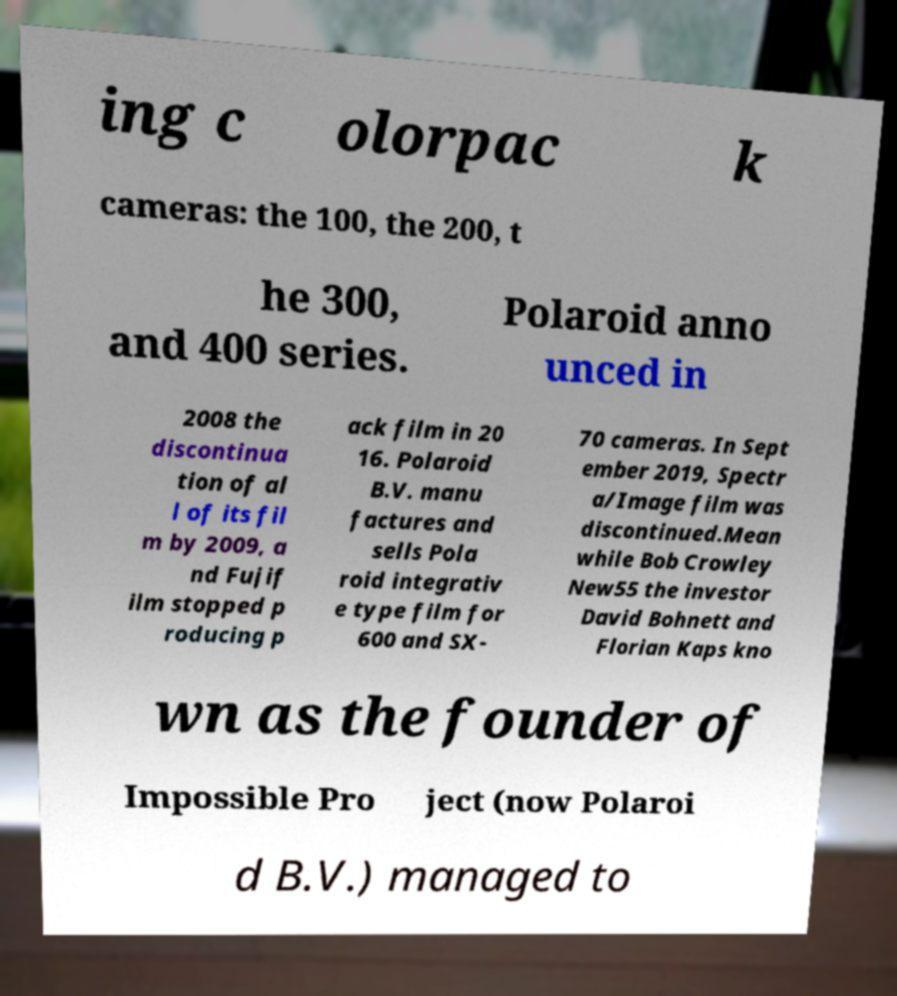There's text embedded in this image that I need extracted. Can you transcribe it verbatim? ing c olorpac k cameras: the 100, the 200, t he 300, and 400 series. Polaroid anno unced in 2008 the discontinua tion of al l of its fil m by 2009, a nd Fujif ilm stopped p roducing p ack film in 20 16. Polaroid B.V. manu factures and sells Pola roid integrativ e type film for 600 and SX- 70 cameras. In Sept ember 2019, Spectr a/Image film was discontinued.Mean while Bob Crowley New55 the investor David Bohnett and Florian Kaps kno wn as the founder of Impossible Pro ject (now Polaroi d B.V.) managed to 